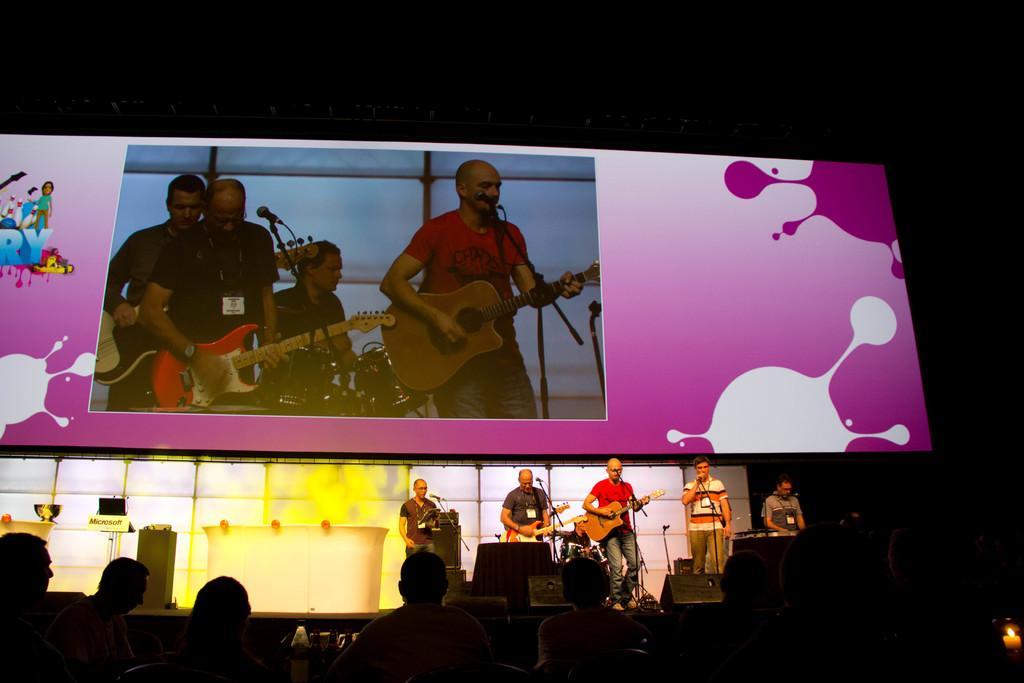Could you give a brief overview of what you see in this image? In this image i can see a group of men are playing guitar and singing a song in front of a microphone on the stage. I can also see there is a big screen on the stage. 